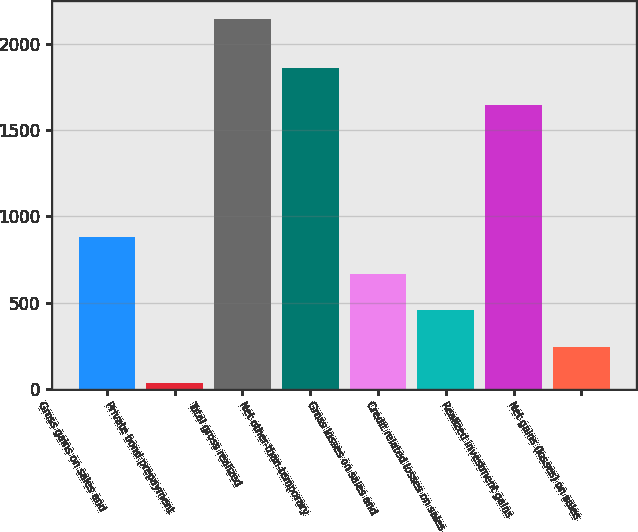<chart> <loc_0><loc_0><loc_500><loc_500><bar_chart><fcel>Gross gains on sales and<fcel>Private bond prepayment<fcel>Total gross realized<fcel>Net other-than-temporary<fcel>Gross losses on sales and<fcel>Credit related losses on sales<fcel>Realized investment gains<fcel>Net gains (losses) on sales<nl><fcel>877.8<fcel>33<fcel>2145<fcel>1858.2<fcel>666.6<fcel>455.4<fcel>1647<fcel>244.2<nl></chart> 